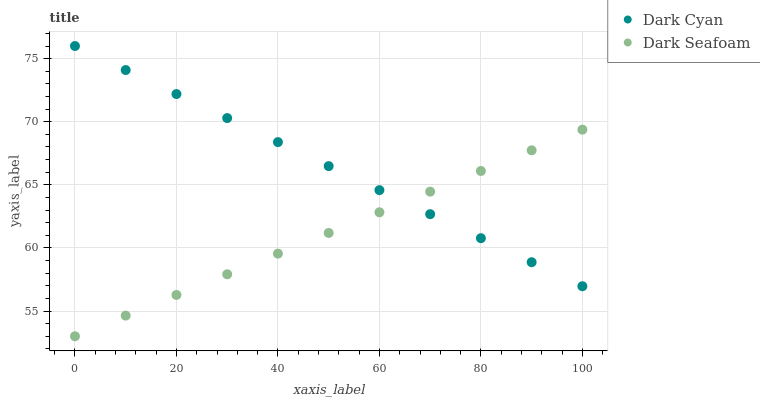Does Dark Seafoam have the minimum area under the curve?
Answer yes or no. Yes. Does Dark Cyan have the maximum area under the curve?
Answer yes or no. Yes. Does Dark Seafoam have the maximum area under the curve?
Answer yes or no. No. Is Dark Cyan the smoothest?
Answer yes or no. Yes. Is Dark Seafoam the roughest?
Answer yes or no. Yes. Does Dark Seafoam have the lowest value?
Answer yes or no. Yes. Does Dark Cyan have the highest value?
Answer yes or no. Yes. Does Dark Seafoam have the highest value?
Answer yes or no. No. Does Dark Seafoam intersect Dark Cyan?
Answer yes or no. Yes. Is Dark Seafoam less than Dark Cyan?
Answer yes or no. No. Is Dark Seafoam greater than Dark Cyan?
Answer yes or no. No. 